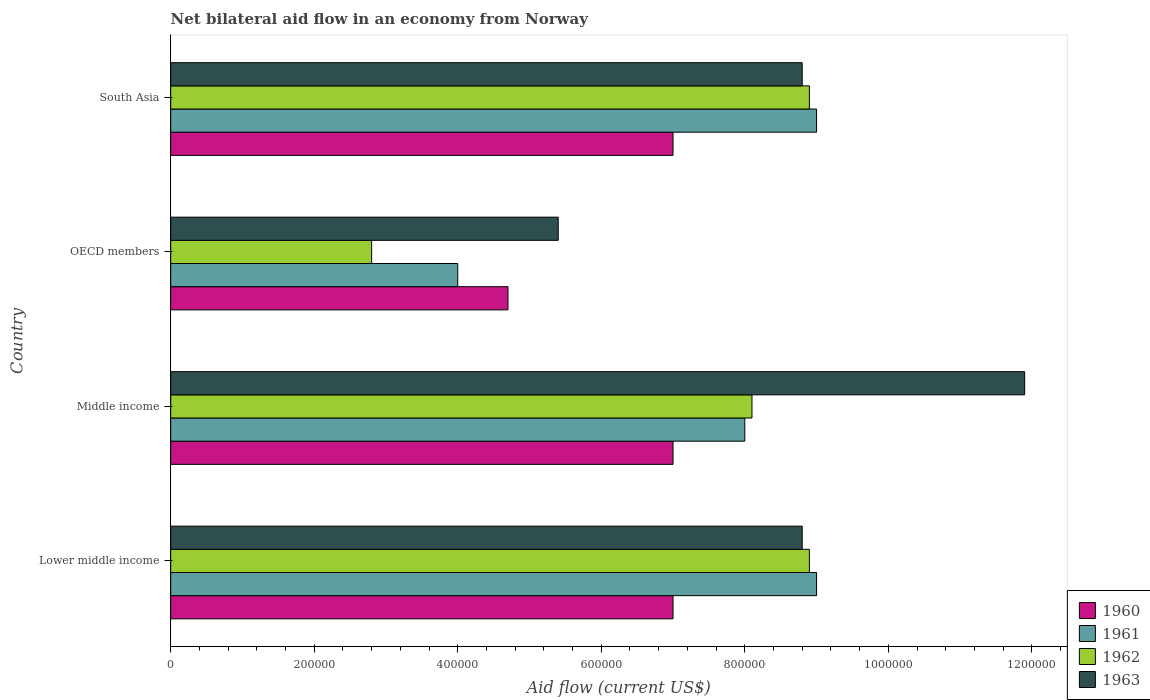Are the number of bars per tick equal to the number of legend labels?
Give a very brief answer. Yes. What is the label of the 4th group of bars from the top?
Provide a short and direct response. Lower middle income. In which country was the net bilateral aid flow in 1960 maximum?
Keep it short and to the point. Lower middle income. What is the total net bilateral aid flow in 1960 in the graph?
Offer a terse response. 2.57e+06. What is the difference between the net bilateral aid flow in 1961 in OECD members and the net bilateral aid flow in 1962 in Lower middle income?
Ensure brevity in your answer.  -4.90e+05. What is the average net bilateral aid flow in 1963 per country?
Your response must be concise. 8.72e+05. In how many countries, is the net bilateral aid flow in 1960 greater than 880000 US$?
Keep it short and to the point. 0. What is the ratio of the net bilateral aid flow in 1963 in Lower middle income to that in OECD members?
Offer a very short reply. 1.63. What is the difference between the highest and the second highest net bilateral aid flow in 1960?
Your response must be concise. 0. In how many countries, is the net bilateral aid flow in 1962 greater than the average net bilateral aid flow in 1962 taken over all countries?
Ensure brevity in your answer.  3. Is the sum of the net bilateral aid flow in 1962 in Middle income and South Asia greater than the maximum net bilateral aid flow in 1963 across all countries?
Your response must be concise. Yes. Is it the case that in every country, the sum of the net bilateral aid flow in 1962 and net bilateral aid flow in 1963 is greater than the sum of net bilateral aid flow in 1960 and net bilateral aid flow in 1961?
Your response must be concise. No. Are all the bars in the graph horizontal?
Your answer should be compact. Yes. What is the title of the graph?
Provide a short and direct response. Net bilateral aid flow in an economy from Norway. What is the label or title of the X-axis?
Provide a short and direct response. Aid flow (current US$). What is the label or title of the Y-axis?
Ensure brevity in your answer.  Country. What is the Aid flow (current US$) of 1962 in Lower middle income?
Ensure brevity in your answer.  8.90e+05. What is the Aid flow (current US$) in 1963 in Lower middle income?
Provide a succinct answer. 8.80e+05. What is the Aid flow (current US$) of 1960 in Middle income?
Keep it short and to the point. 7.00e+05. What is the Aid flow (current US$) of 1961 in Middle income?
Offer a terse response. 8.00e+05. What is the Aid flow (current US$) in 1962 in Middle income?
Your answer should be very brief. 8.10e+05. What is the Aid flow (current US$) in 1963 in Middle income?
Give a very brief answer. 1.19e+06. What is the Aid flow (current US$) in 1960 in OECD members?
Your answer should be compact. 4.70e+05. What is the Aid flow (current US$) in 1962 in OECD members?
Offer a terse response. 2.80e+05. What is the Aid flow (current US$) of 1963 in OECD members?
Your answer should be very brief. 5.40e+05. What is the Aid flow (current US$) in 1960 in South Asia?
Make the answer very short. 7.00e+05. What is the Aid flow (current US$) of 1962 in South Asia?
Keep it short and to the point. 8.90e+05. What is the Aid flow (current US$) of 1963 in South Asia?
Your response must be concise. 8.80e+05. Across all countries, what is the maximum Aid flow (current US$) of 1960?
Offer a very short reply. 7.00e+05. Across all countries, what is the maximum Aid flow (current US$) of 1962?
Provide a short and direct response. 8.90e+05. Across all countries, what is the maximum Aid flow (current US$) in 1963?
Your response must be concise. 1.19e+06. Across all countries, what is the minimum Aid flow (current US$) in 1961?
Your response must be concise. 4.00e+05. Across all countries, what is the minimum Aid flow (current US$) of 1962?
Provide a short and direct response. 2.80e+05. Across all countries, what is the minimum Aid flow (current US$) of 1963?
Make the answer very short. 5.40e+05. What is the total Aid flow (current US$) in 1960 in the graph?
Make the answer very short. 2.57e+06. What is the total Aid flow (current US$) in 1962 in the graph?
Provide a succinct answer. 2.87e+06. What is the total Aid flow (current US$) in 1963 in the graph?
Your answer should be very brief. 3.49e+06. What is the difference between the Aid flow (current US$) in 1960 in Lower middle income and that in Middle income?
Provide a short and direct response. 0. What is the difference between the Aid flow (current US$) in 1961 in Lower middle income and that in Middle income?
Provide a short and direct response. 1.00e+05. What is the difference between the Aid flow (current US$) of 1962 in Lower middle income and that in Middle income?
Ensure brevity in your answer.  8.00e+04. What is the difference between the Aid flow (current US$) in 1963 in Lower middle income and that in Middle income?
Keep it short and to the point. -3.10e+05. What is the difference between the Aid flow (current US$) in 1960 in Lower middle income and that in OECD members?
Offer a terse response. 2.30e+05. What is the difference between the Aid flow (current US$) in 1961 in Lower middle income and that in OECD members?
Offer a very short reply. 5.00e+05. What is the difference between the Aid flow (current US$) in 1962 in Lower middle income and that in OECD members?
Keep it short and to the point. 6.10e+05. What is the difference between the Aid flow (current US$) of 1961 in Lower middle income and that in South Asia?
Ensure brevity in your answer.  0. What is the difference between the Aid flow (current US$) in 1962 in Lower middle income and that in South Asia?
Your answer should be compact. 0. What is the difference between the Aid flow (current US$) in 1963 in Lower middle income and that in South Asia?
Your answer should be compact. 0. What is the difference between the Aid flow (current US$) of 1960 in Middle income and that in OECD members?
Provide a succinct answer. 2.30e+05. What is the difference between the Aid flow (current US$) in 1961 in Middle income and that in OECD members?
Provide a short and direct response. 4.00e+05. What is the difference between the Aid flow (current US$) of 1962 in Middle income and that in OECD members?
Ensure brevity in your answer.  5.30e+05. What is the difference between the Aid flow (current US$) in 1963 in Middle income and that in OECD members?
Your answer should be very brief. 6.50e+05. What is the difference between the Aid flow (current US$) in 1961 in Middle income and that in South Asia?
Your answer should be compact. -1.00e+05. What is the difference between the Aid flow (current US$) of 1962 in Middle income and that in South Asia?
Keep it short and to the point. -8.00e+04. What is the difference between the Aid flow (current US$) in 1961 in OECD members and that in South Asia?
Provide a succinct answer. -5.00e+05. What is the difference between the Aid flow (current US$) of 1962 in OECD members and that in South Asia?
Make the answer very short. -6.10e+05. What is the difference between the Aid flow (current US$) of 1960 in Lower middle income and the Aid flow (current US$) of 1963 in Middle income?
Provide a succinct answer. -4.90e+05. What is the difference between the Aid flow (current US$) of 1961 in Lower middle income and the Aid flow (current US$) of 1962 in Middle income?
Provide a succinct answer. 9.00e+04. What is the difference between the Aid flow (current US$) of 1961 in Lower middle income and the Aid flow (current US$) of 1963 in Middle income?
Your answer should be very brief. -2.90e+05. What is the difference between the Aid flow (current US$) in 1960 in Lower middle income and the Aid flow (current US$) in 1962 in OECD members?
Give a very brief answer. 4.20e+05. What is the difference between the Aid flow (current US$) of 1960 in Lower middle income and the Aid flow (current US$) of 1963 in OECD members?
Offer a very short reply. 1.60e+05. What is the difference between the Aid flow (current US$) of 1961 in Lower middle income and the Aid flow (current US$) of 1962 in OECD members?
Keep it short and to the point. 6.20e+05. What is the difference between the Aid flow (current US$) in 1961 in Lower middle income and the Aid flow (current US$) in 1963 in OECD members?
Your answer should be compact. 3.60e+05. What is the difference between the Aid flow (current US$) in 1960 in Lower middle income and the Aid flow (current US$) in 1963 in South Asia?
Your answer should be compact. -1.80e+05. What is the difference between the Aid flow (current US$) in 1961 in Lower middle income and the Aid flow (current US$) in 1962 in South Asia?
Your response must be concise. 10000. What is the difference between the Aid flow (current US$) in 1962 in Lower middle income and the Aid flow (current US$) in 1963 in South Asia?
Give a very brief answer. 10000. What is the difference between the Aid flow (current US$) in 1960 in Middle income and the Aid flow (current US$) in 1961 in OECD members?
Your answer should be compact. 3.00e+05. What is the difference between the Aid flow (current US$) of 1960 in Middle income and the Aid flow (current US$) of 1963 in OECD members?
Your response must be concise. 1.60e+05. What is the difference between the Aid flow (current US$) in 1961 in Middle income and the Aid flow (current US$) in 1962 in OECD members?
Make the answer very short. 5.20e+05. What is the difference between the Aid flow (current US$) of 1960 in Middle income and the Aid flow (current US$) of 1961 in South Asia?
Make the answer very short. -2.00e+05. What is the difference between the Aid flow (current US$) of 1960 in Middle income and the Aid flow (current US$) of 1962 in South Asia?
Your response must be concise. -1.90e+05. What is the difference between the Aid flow (current US$) of 1961 in Middle income and the Aid flow (current US$) of 1962 in South Asia?
Provide a short and direct response. -9.00e+04. What is the difference between the Aid flow (current US$) of 1961 in Middle income and the Aid flow (current US$) of 1963 in South Asia?
Give a very brief answer. -8.00e+04. What is the difference between the Aid flow (current US$) in 1960 in OECD members and the Aid flow (current US$) in 1961 in South Asia?
Ensure brevity in your answer.  -4.30e+05. What is the difference between the Aid flow (current US$) of 1960 in OECD members and the Aid flow (current US$) of 1962 in South Asia?
Your answer should be very brief. -4.20e+05. What is the difference between the Aid flow (current US$) in 1960 in OECD members and the Aid flow (current US$) in 1963 in South Asia?
Offer a very short reply. -4.10e+05. What is the difference between the Aid flow (current US$) of 1961 in OECD members and the Aid flow (current US$) of 1962 in South Asia?
Your answer should be compact. -4.90e+05. What is the difference between the Aid flow (current US$) in 1961 in OECD members and the Aid flow (current US$) in 1963 in South Asia?
Offer a very short reply. -4.80e+05. What is the difference between the Aid flow (current US$) of 1962 in OECD members and the Aid flow (current US$) of 1963 in South Asia?
Offer a very short reply. -6.00e+05. What is the average Aid flow (current US$) in 1960 per country?
Make the answer very short. 6.42e+05. What is the average Aid flow (current US$) of 1961 per country?
Provide a short and direct response. 7.50e+05. What is the average Aid flow (current US$) in 1962 per country?
Give a very brief answer. 7.18e+05. What is the average Aid flow (current US$) of 1963 per country?
Provide a succinct answer. 8.72e+05. What is the difference between the Aid flow (current US$) in 1960 and Aid flow (current US$) in 1962 in Lower middle income?
Keep it short and to the point. -1.90e+05. What is the difference between the Aid flow (current US$) of 1960 and Aid flow (current US$) of 1963 in Lower middle income?
Give a very brief answer. -1.80e+05. What is the difference between the Aid flow (current US$) of 1962 and Aid flow (current US$) of 1963 in Lower middle income?
Your answer should be compact. 10000. What is the difference between the Aid flow (current US$) of 1960 and Aid flow (current US$) of 1961 in Middle income?
Your answer should be compact. -1.00e+05. What is the difference between the Aid flow (current US$) in 1960 and Aid flow (current US$) in 1962 in Middle income?
Your answer should be compact. -1.10e+05. What is the difference between the Aid flow (current US$) in 1960 and Aid flow (current US$) in 1963 in Middle income?
Offer a very short reply. -4.90e+05. What is the difference between the Aid flow (current US$) of 1961 and Aid flow (current US$) of 1962 in Middle income?
Your response must be concise. -10000. What is the difference between the Aid flow (current US$) in 1961 and Aid flow (current US$) in 1963 in Middle income?
Your answer should be compact. -3.90e+05. What is the difference between the Aid flow (current US$) in 1962 and Aid flow (current US$) in 1963 in Middle income?
Your answer should be very brief. -3.80e+05. What is the difference between the Aid flow (current US$) in 1960 and Aid flow (current US$) in 1961 in OECD members?
Give a very brief answer. 7.00e+04. What is the difference between the Aid flow (current US$) in 1960 and Aid flow (current US$) in 1962 in OECD members?
Provide a succinct answer. 1.90e+05. What is the difference between the Aid flow (current US$) of 1961 and Aid flow (current US$) of 1962 in OECD members?
Your answer should be compact. 1.20e+05. What is the difference between the Aid flow (current US$) of 1960 and Aid flow (current US$) of 1961 in South Asia?
Make the answer very short. -2.00e+05. What is the difference between the Aid flow (current US$) in 1960 and Aid flow (current US$) in 1963 in South Asia?
Your answer should be very brief. -1.80e+05. What is the difference between the Aid flow (current US$) of 1961 and Aid flow (current US$) of 1963 in South Asia?
Ensure brevity in your answer.  2.00e+04. What is the ratio of the Aid flow (current US$) in 1960 in Lower middle income to that in Middle income?
Your response must be concise. 1. What is the ratio of the Aid flow (current US$) of 1962 in Lower middle income to that in Middle income?
Your answer should be very brief. 1.1. What is the ratio of the Aid flow (current US$) of 1963 in Lower middle income to that in Middle income?
Your answer should be very brief. 0.74. What is the ratio of the Aid flow (current US$) in 1960 in Lower middle income to that in OECD members?
Provide a short and direct response. 1.49. What is the ratio of the Aid flow (current US$) in 1961 in Lower middle income to that in OECD members?
Make the answer very short. 2.25. What is the ratio of the Aid flow (current US$) in 1962 in Lower middle income to that in OECD members?
Offer a very short reply. 3.18. What is the ratio of the Aid flow (current US$) of 1963 in Lower middle income to that in OECD members?
Your answer should be compact. 1.63. What is the ratio of the Aid flow (current US$) in 1960 in Lower middle income to that in South Asia?
Ensure brevity in your answer.  1. What is the ratio of the Aid flow (current US$) in 1961 in Lower middle income to that in South Asia?
Make the answer very short. 1. What is the ratio of the Aid flow (current US$) of 1960 in Middle income to that in OECD members?
Provide a short and direct response. 1.49. What is the ratio of the Aid flow (current US$) of 1961 in Middle income to that in OECD members?
Your answer should be very brief. 2. What is the ratio of the Aid flow (current US$) in 1962 in Middle income to that in OECD members?
Your answer should be compact. 2.89. What is the ratio of the Aid flow (current US$) of 1963 in Middle income to that in OECD members?
Give a very brief answer. 2.2. What is the ratio of the Aid flow (current US$) of 1961 in Middle income to that in South Asia?
Your answer should be compact. 0.89. What is the ratio of the Aid flow (current US$) of 1962 in Middle income to that in South Asia?
Offer a very short reply. 0.91. What is the ratio of the Aid flow (current US$) in 1963 in Middle income to that in South Asia?
Ensure brevity in your answer.  1.35. What is the ratio of the Aid flow (current US$) in 1960 in OECD members to that in South Asia?
Provide a short and direct response. 0.67. What is the ratio of the Aid flow (current US$) of 1961 in OECD members to that in South Asia?
Provide a short and direct response. 0.44. What is the ratio of the Aid flow (current US$) in 1962 in OECD members to that in South Asia?
Your answer should be very brief. 0.31. What is the ratio of the Aid flow (current US$) in 1963 in OECD members to that in South Asia?
Keep it short and to the point. 0.61. What is the difference between the highest and the second highest Aid flow (current US$) in 1962?
Ensure brevity in your answer.  0. What is the difference between the highest and the lowest Aid flow (current US$) in 1962?
Provide a succinct answer. 6.10e+05. What is the difference between the highest and the lowest Aid flow (current US$) of 1963?
Provide a short and direct response. 6.50e+05. 